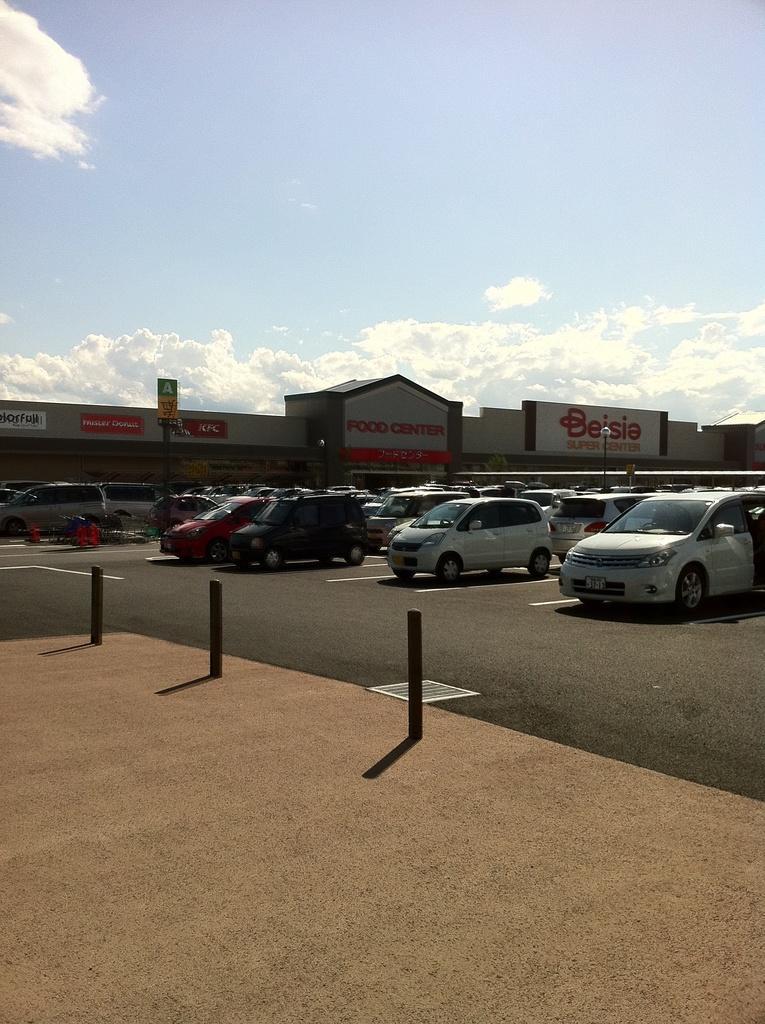Could you give a brief overview of what you see in this image? In this picture I can see vehicles, there is a building, there are boards, and in the background there is the sky. 